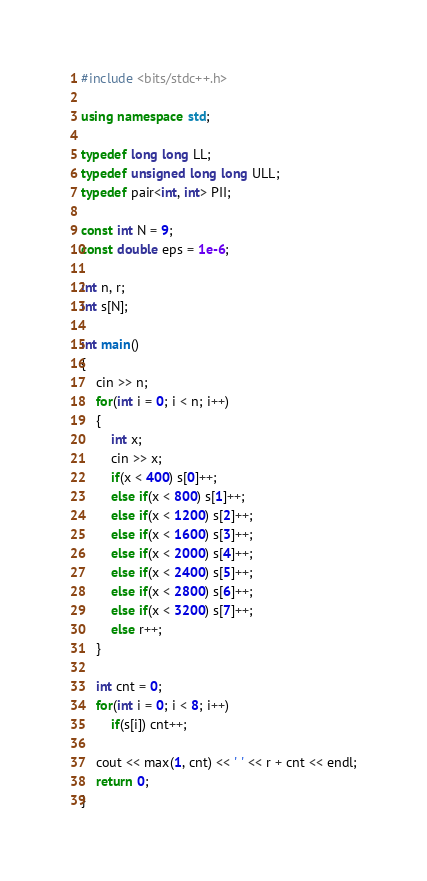<code> <loc_0><loc_0><loc_500><loc_500><_C++_>#include <bits/stdc++.h>

using namespace std;

typedef long long LL;
typedef unsigned long long ULL;
typedef pair<int, int> PII;

const int N = 9;
const double eps = 1e-6;

int n, r;
int s[N];

int main()
{
    cin >> n;
    for(int i = 0; i < n; i++)
    {
        int x;
        cin >> x;
        if(x < 400) s[0]++;
        else if(x < 800) s[1]++;
        else if(x < 1200) s[2]++;
        else if(x < 1600) s[3]++;
        else if(x < 2000) s[4]++;
        else if(x < 2400) s[5]++;
        else if(x < 2800) s[6]++;
        else if(x < 3200) s[7]++;
        else r++;
    }

    int cnt = 0;
    for(int i = 0; i < 8; i++)
        if(s[i]) cnt++;

    cout << max(1, cnt) << ' ' << r + cnt << endl;
    return 0;
}
</code> 